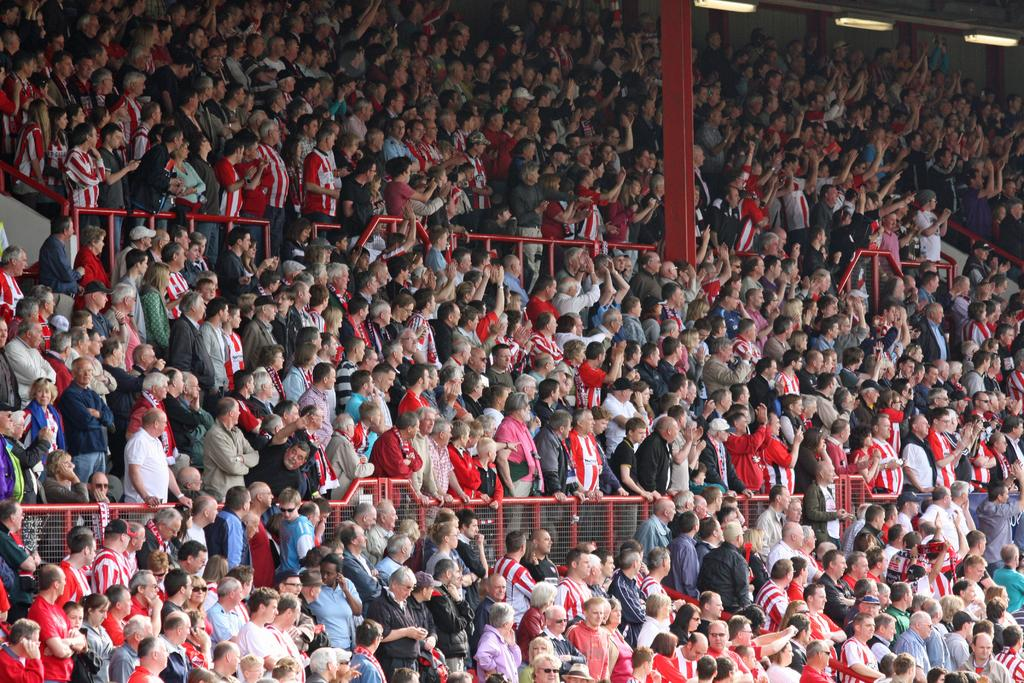What type of structure is depicted in the image? The image contains a stadium. How many people are present in the stadium? The stadium is filled with people. Can you describe any specific architectural features in the image? There is a pillar on the top right of the image. What might be used to separate or enclose different sections of the stadium? There are fences between the people in the stadium. What type of soup is being served to the people in the image? There is no soup present in the image; it features a stadium filled with people. Can you describe the view from the top of the hammer in the image? There is no hammer present in the image, so it is not possible to describe a view from the top of it. 